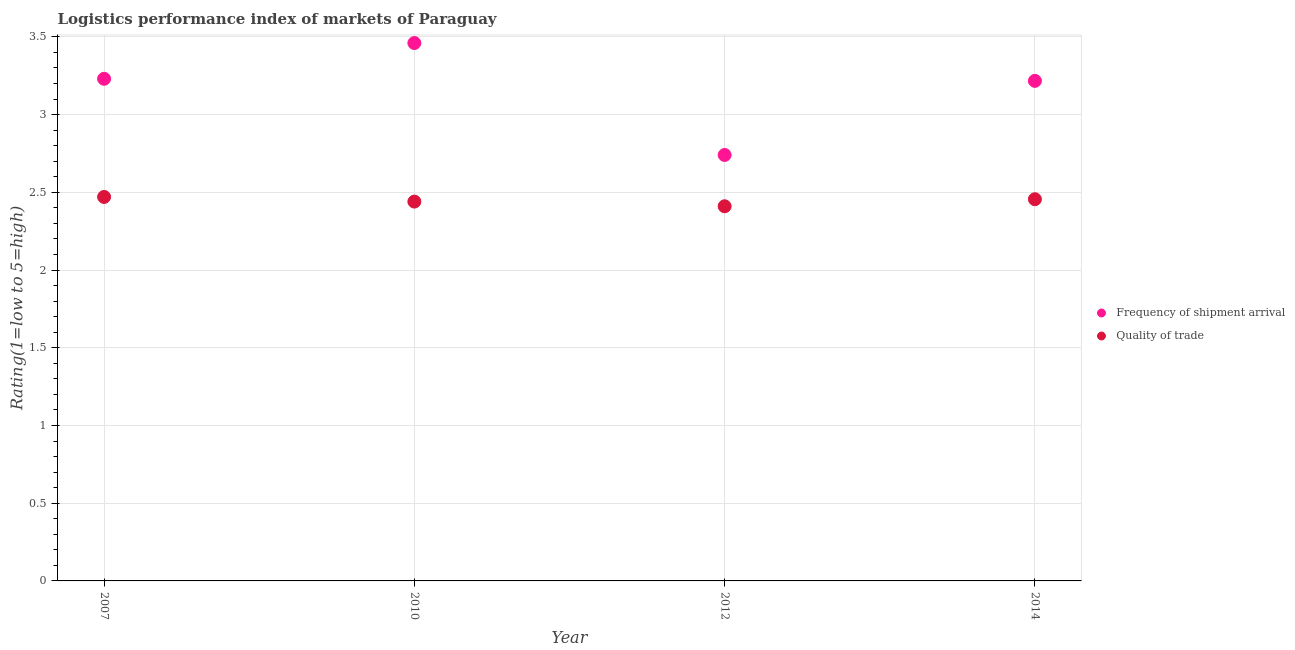How many different coloured dotlines are there?
Offer a very short reply. 2. What is the lpi quality of trade in 2007?
Your response must be concise. 2.47. Across all years, what is the maximum lpi of frequency of shipment arrival?
Provide a short and direct response. 3.46. Across all years, what is the minimum lpi of frequency of shipment arrival?
Provide a succinct answer. 2.74. In which year was the lpi of frequency of shipment arrival minimum?
Your answer should be very brief. 2012. What is the total lpi of frequency of shipment arrival in the graph?
Your answer should be compact. 12.65. What is the difference between the lpi of frequency of shipment arrival in 2010 and that in 2012?
Your answer should be compact. 0.72. What is the difference between the lpi of frequency of shipment arrival in 2010 and the lpi quality of trade in 2012?
Offer a terse response. 1.05. What is the average lpi quality of trade per year?
Your answer should be very brief. 2.44. In the year 2007, what is the difference between the lpi quality of trade and lpi of frequency of shipment arrival?
Your answer should be very brief. -0.76. In how many years, is the lpi of frequency of shipment arrival greater than 2.8?
Your response must be concise. 3. What is the ratio of the lpi of frequency of shipment arrival in 2010 to that in 2014?
Make the answer very short. 1.08. Is the lpi quality of trade in 2012 less than that in 2014?
Your answer should be compact. Yes. Is the difference between the lpi quality of trade in 2007 and 2012 greater than the difference between the lpi of frequency of shipment arrival in 2007 and 2012?
Provide a short and direct response. No. What is the difference between the highest and the second highest lpi of frequency of shipment arrival?
Provide a succinct answer. 0.23. What is the difference between the highest and the lowest lpi of frequency of shipment arrival?
Keep it short and to the point. 0.72. In how many years, is the lpi quality of trade greater than the average lpi quality of trade taken over all years?
Provide a short and direct response. 2. Is the sum of the lpi quality of trade in 2007 and 2014 greater than the maximum lpi of frequency of shipment arrival across all years?
Make the answer very short. Yes. Is the lpi quality of trade strictly less than the lpi of frequency of shipment arrival over the years?
Your answer should be very brief. Yes. How many years are there in the graph?
Your response must be concise. 4. Does the graph contain any zero values?
Provide a short and direct response. No. Does the graph contain grids?
Give a very brief answer. Yes. Where does the legend appear in the graph?
Your answer should be very brief. Center right. How many legend labels are there?
Provide a succinct answer. 2. How are the legend labels stacked?
Your response must be concise. Vertical. What is the title of the graph?
Offer a very short reply. Logistics performance index of markets of Paraguay. What is the label or title of the Y-axis?
Ensure brevity in your answer.  Rating(1=low to 5=high). What is the Rating(1=low to 5=high) of Frequency of shipment arrival in 2007?
Provide a short and direct response. 3.23. What is the Rating(1=low to 5=high) of Quality of trade in 2007?
Your response must be concise. 2.47. What is the Rating(1=low to 5=high) in Frequency of shipment arrival in 2010?
Offer a terse response. 3.46. What is the Rating(1=low to 5=high) in Quality of trade in 2010?
Give a very brief answer. 2.44. What is the Rating(1=low to 5=high) of Frequency of shipment arrival in 2012?
Your answer should be very brief. 2.74. What is the Rating(1=low to 5=high) in Quality of trade in 2012?
Your answer should be compact. 2.41. What is the Rating(1=low to 5=high) in Frequency of shipment arrival in 2014?
Offer a very short reply. 3.22. What is the Rating(1=low to 5=high) of Quality of trade in 2014?
Provide a succinct answer. 2.46. Across all years, what is the maximum Rating(1=low to 5=high) in Frequency of shipment arrival?
Make the answer very short. 3.46. Across all years, what is the maximum Rating(1=low to 5=high) in Quality of trade?
Keep it short and to the point. 2.47. Across all years, what is the minimum Rating(1=low to 5=high) of Frequency of shipment arrival?
Your answer should be very brief. 2.74. Across all years, what is the minimum Rating(1=low to 5=high) in Quality of trade?
Your answer should be compact. 2.41. What is the total Rating(1=low to 5=high) in Frequency of shipment arrival in the graph?
Your answer should be compact. 12.65. What is the total Rating(1=low to 5=high) in Quality of trade in the graph?
Provide a succinct answer. 9.78. What is the difference between the Rating(1=low to 5=high) of Frequency of shipment arrival in 2007 and that in 2010?
Your answer should be very brief. -0.23. What is the difference between the Rating(1=low to 5=high) of Quality of trade in 2007 and that in 2010?
Give a very brief answer. 0.03. What is the difference between the Rating(1=low to 5=high) in Frequency of shipment arrival in 2007 and that in 2012?
Keep it short and to the point. 0.49. What is the difference between the Rating(1=low to 5=high) of Quality of trade in 2007 and that in 2012?
Offer a very short reply. 0.06. What is the difference between the Rating(1=low to 5=high) in Frequency of shipment arrival in 2007 and that in 2014?
Offer a very short reply. 0.01. What is the difference between the Rating(1=low to 5=high) in Quality of trade in 2007 and that in 2014?
Offer a very short reply. 0.01. What is the difference between the Rating(1=low to 5=high) in Frequency of shipment arrival in 2010 and that in 2012?
Make the answer very short. 0.72. What is the difference between the Rating(1=low to 5=high) in Frequency of shipment arrival in 2010 and that in 2014?
Give a very brief answer. 0.24. What is the difference between the Rating(1=low to 5=high) in Quality of trade in 2010 and that in 2014?
Ensure brevity in your answer.  -0.02. What is the difference between the Rating(1=low to 5=high) in Frequency of shipment arrival in 2012 and that in 2014?
Ensure brevity in your answer.  -0.48. What is the difference between the Rating(1=low to 5=high) in Quality of trade in 2012 and that in 2014?
Keep it short and to the point. -0.05. What is the difference between the Rating(1=low to 5=high) of Frequency of shipment arrival in 2007 and the Rating(1=low to 5=high) of Quality of trade in 2010?
Make the answer very short. 0.79. What is the difference between the Rating(1=low to 5=high) in Frequency of shipment arrival in 2007 and the Rating(1=low to 5=high) in Quality of trade in 2012?
Ensure brevity in your answer.  0.82. What is the difference between the Rating(1=low to 5=high) of Frequency of shipment arrival in 2007 and the Rating(1=low to 5=high) of Quality of trade in 2014?
Offer a terse response. 0.77. What is the difference between the Rating(1=low to 5=high) in Frequency of shipment arrival in 2010 and the Rating(1=low to 5=high) in Quality of trade in 2012?
Your answer should be very brief. 1.05. What is the difference between the Rating(1=low to 5=high) in Frequency of shipment arrival in 2010 and the Rating(1=low to 5=high) in Quality of trade in 2014?
Ensure brevity in your answer.  1. What is the difference between the Rating(1=low to 5=high) of Frequency of shipment arrival in 2012 and the Rating(1=low to 5=high) of Quality of trade in 2014?
Give a very brief answer. 0.28. What is the average Rating(1=low to 5=high) in Frequency of shipment arrival per year?
Your answer should be compact. 3.16. What is the average Rating(1=low to 5=high) in Quality of trade per year?
Offer a very short reply. 2.44. In the year 2007, what is the difference between the Rating(1=low to 5=high) in Frequency of shipment arrival and Rating(1=low to 5=high) in Quality of trade?
Your answer should be compact. 0.76. In the year 2010, what is the difference between the Rating(1=low to 5=high) of Frequency of shipment arrival and Rating(1=low to 5=high) of Quality of trade?
Provide a succinct answer. 1.02. In the year 2012, what is the difference between the Rating(1=low to 5=high) of Frequency of shipment arrival and Rating(1=low to 5=high) of Quality of trade?
Your response must be concise. 0.33. In the year 2014, what is the difference between the Rating(1=low to 5=high) in Frequency of shipment arrival and Rating(1=low to 5=high) in Quality of trade?
Your answer should be compact. 0.76. What is the ratio of the Rating(1=low to 5=high) of Frequency of shipment arrival in 2007 to that in 2010?
Offer a very short reply. 0.93. What is the ratio of the Rating(1=low to 5=high) in Quality of trade in 2007 to that in 2010?
Your answer should be very brief. 1.01. What is the ratio of the Rating(1=low to 5=high) of Frequency of shipment arrival in 2007 to that in 2012?
Provide a short and direct response. 1.18. What is the ratio of the Rating(1=low to 5=high) of Quality of trade in 2007 to that in 2012?
Make the answer very short. 1.02. What is the ratio of the Rating(1=low to 5=high) of Quality of trade in 2007 to that in 2014?
Give a very brief answer. 1.01. What is the ratio of the Rating(1=low to 5=high) in Frequency of shipment arrival in 2010 to that in 2012?
Provide a short and direct response. 1.26. What is the ratio of the Rating(1=low to 5=high) of Quality of trade in 2010 to that in 2012?
Provide a succinct answer. 1.01. What is the ratio of the Rating(1=low to 5=high) of Frequency of shipment arrival in 2010 to that in 2014?
Make the answer very short. 1.08. What is the ratio of the Rating(1=low to 5=high) of Frequency of shipment arrival in 2012 to that in 2014?
Keep it short and to the point. 0.85. What is the ratio of the Rating(1=low to 5=high) in Quality of trade in 2012 to that in 2014?
Your answer should be compact. 0.98. What is the difference between the highest and the second highest Rating(1=low to 5=high) in Frequency of shipment arrival?
Offer a very short reply. 0.23. What is the difference between the highest and the second highest Rating(1=low to 5=high) of Quality of trade?
Provide a short and direct response. 0.01. What is the difference between the highest and the lowest Rating(1=low to 5=high) in Frequency of shipment arrival?
Your response must be concise. 0.72. What is the difference between the highest and the lowest Rating(1=low to 5=high) of Quality of trade?
Your answer should be very brief. 0.06. 